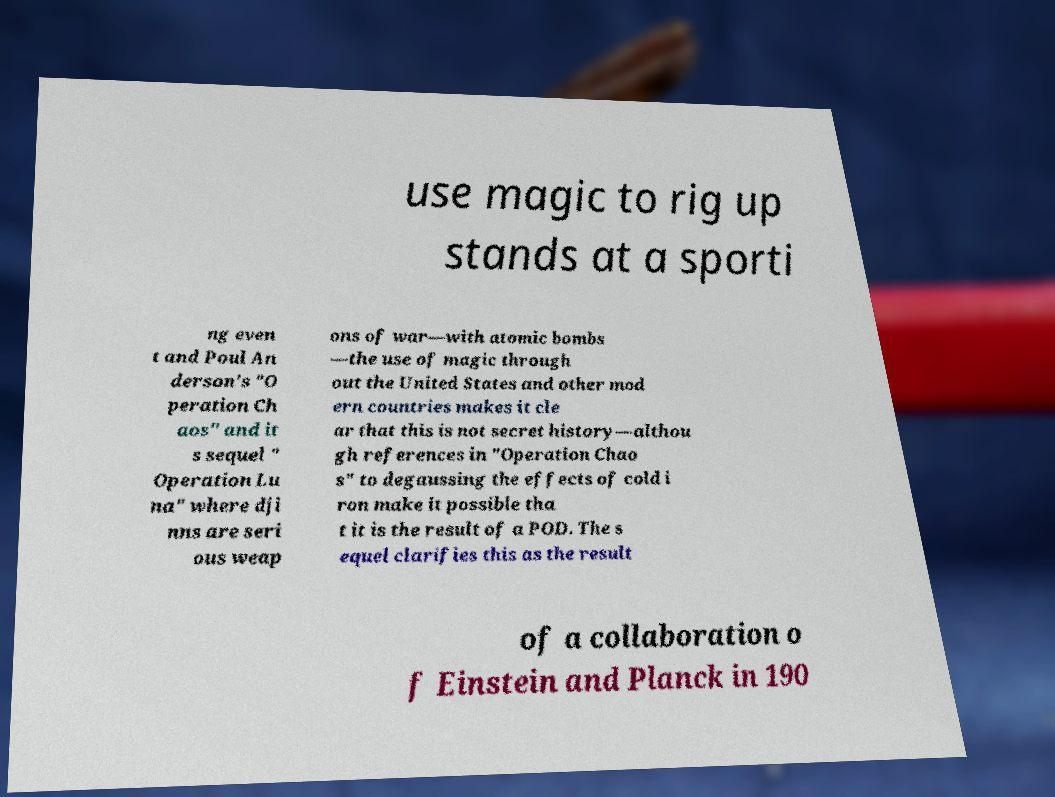What messages or text are displayed in this image? I need them in a readable, typed format. use magic to rig up stands at a sporti ng even t and Poul An derson's "O peration Ch aos" and it s sequel " Operation Lu na" where dji nns are seri ous weap ons of war—with atomic bombs —the use of magic through out the United States and other mod ern countries makes it cle ar that this is not secret history—althou gh references in "Operation Chao s" to degaussing the effects of cold i ron make it possible tha t it is the result of a POD. The s equel clarifies this as the result of a collaboration o f Einstein and Planck in 190 